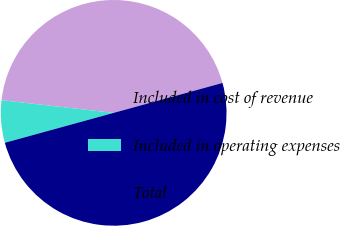Convert chart to OTSL. <chart><loc_0><loc_0><loc_500><loc_500><pie_chart><fcel>Included in cost of revenue<fcel>Included in operating expenses<fcel>Total<nl><fcel>43.94%<fcel>6.06%<fcel>50.0%<nl></chart> 